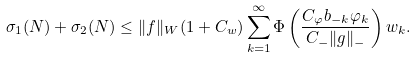<formula> <loc_0><loc_0><loc_500><loc_500>\sigma _ { 1 } ( N ) + \sigma _ { 2 } ( N ) \leq \| f \| _ { W } ( 1 + C _ { w } ) \sum _ { k = 1 } ^ { \infty } \Phi \left ( \frac { C _ { \varphi } b _ { - k } \varphi _ { k } } { C _ { - } \| g \| _ { - } } \right ) w _ { k } .</formula> 